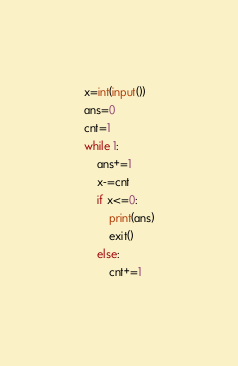<code> <loc_0><loc_0><loc_500><loc_500><_Python_>x=int(input())
ans=0
cnt=1
while 1:
    ans+=1
    x-=cnt
    if x<=0:
        print(ans)
        exit()
    else:
        cnt+=1</code> 